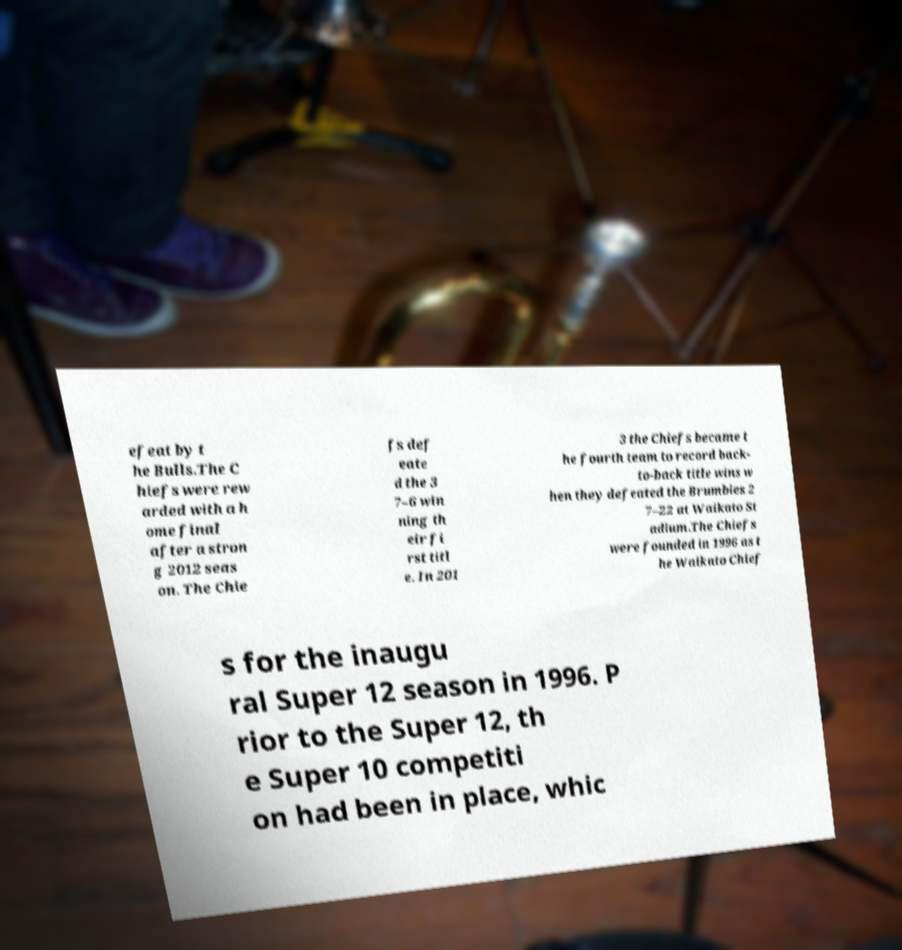Can you accurately transcribe the text from the provided image for me? efeat by t he Bulls.The C hiefs were rew arded with a h ome final after a stron g 2012 seas on. The Chie fs def eate d the 3 7–6 win ning th eir fi rst titl e. In 201 3 the Chiefs became t he fourth team to record back- to-back title wins w hen they defeated the Brumbies 2 7–22 at Waikato St adium.The Chiefs were founded in 1996 as t he Waikato Chief s for the inaugu ral Super 12 season in 1996. P rior to the Super 12, th e Super 10 competiti on had been in place, whic 